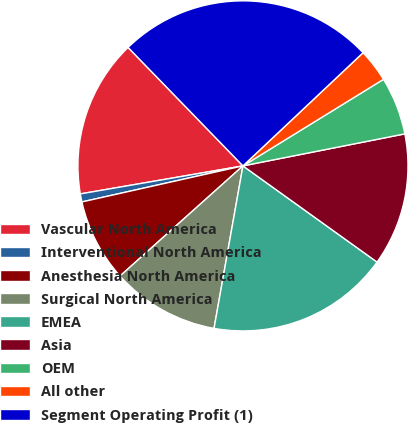<chart> <loc_0><loc_0><loc_500><loc_500><pie_chart><fcel>Vascular North America<fcel>Interventional North America<fcel>Anesthesia North America<fcel>Surgical North America<fcel>EMEA<fcel>Asia<fcel>OEM<fcel>All other<fcel>Segment Operating Profit (1)<nl><fcel>15.46%<fcel>0.79%<fcel>8.12%<fcel>10.57%<fcel>17.9%<fcel>13.01%<fcel>5.68%<fcel>3.24%<fcel>25.23%<nl></chart> 